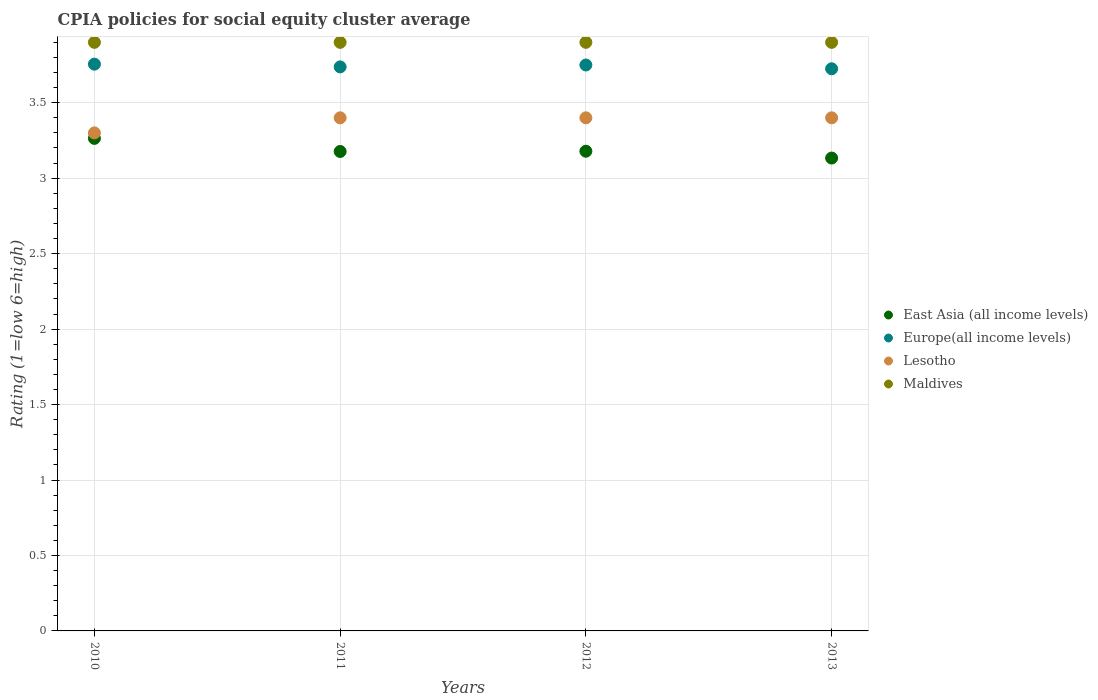Is the number of dotlines equal to the number of legend labels?
Ensure brevity in your answer.  Yes. What is the CPIA rating in Maldives in 2011?
Your answer should be compact. 3.9. Across all years, what is the maximum CPIA rating in East Asia (all income levels)?
Your response must be concise. 3.26. Across all years, what is the minimum CPIA rating in Maldives?
Make the answer very short. 3.9. What is the total CPIA rating in East Asia (all income levels) in the graph?
Your response must be concise. 12.75. What is the difference between the CPIA rating in Maldives in 2010 and that in 2012?
Provide a succinct answer. 0. What is the difference between the CPIA rating in Lesotho in 2011 and the CPIA rating in Europe(all income levels) in 2010?
Offer a terse response. -0.36. What is the average CPIA rating in Lesotho per year?
Provide a succinct answer. 3.38. In the year 2013, what is the difference between the CPIA rating in Europe(all income levels) and CPIA rating in Maldives?
Offer a very short reply. -0.17. What is the ratio of the CPIA rating in Lesotho in 2010 to that in 2011?
Your answer should be compact. 0.97. Is the CPIA rating in Europe(all income levels) in 2011 less than that in 2013?
Provide a succinct answer. No. Is the difference between the CPIA rating in Europe(all income levels) in 2010 and 2013 greater than the difference between the CPIA rating in Maldives in 2010 and 2013?
Your answer should be compact. Yes. What is the difference between the highest and the second highest CPIA rating in East Asia (all income levels)?
Your response must be concise. 0.09. Is the sum of the CPIA rating in Europe(all income levels) in 2010 and 2012 greater than the maximum CPIA rating in Lesotho across all years?
Offer a terse response. Yes. Is it the case that in every year, the sum of the CPIA rating in Lesotho and CPIA rating in Maldives  is greater than the sum of CPIA rating in Europe(all income levels) and CPIA rating in East Asia (all income levels)?
Offer a very short reply. No. Is it the case that in every year, the sum of the CPIA rating in Europe(all income levels) and CPIA rating in Lesotho  is greater than the CPIA rating in East Asia (all income levels)?
Provide a short and direct response. Yes. Does the CPIA rating in Lesotho monotonically increase over the years?
Your answer should be compact. No. How many dotlines are there?
Give a very brief answer. 4. What is the difference between two consecutive major ticks on the Y-axis?
Your answer should be very brief. 0.5. Are the values on the major ticks of Y-axis written in scientific E-notation?
Your answer should be compact. No. Does the graph contain any zero values?
Provide a succinct answer. No. How many legend labels are there?
Your answer should be very brief. 4. How are the legend labels stacked?
Give a very brief answer. Vertical. What is the title of the graph?
Your answer should be compact. CPIA policies for social equity cluster average. What is the label or title of the X-axis?
Your answer should be compact. Years. What is the Rating (1=low 6=high) in East Asia (all income levels) in 2010?
Provide a succinct answer. 3.26. What is the Rating (1=low 6=high) in Europe(all income levels) in 2010?
Offer a terse response. 3.76. What is the Rating (1=low 6=high) in East Asia (all income levels) in 2011?
Provide a succinct answer. 3.18. What is the Rating (1=low 6=high) of Europe(all income levels) in 2011?
Ensure brevity in your answer.  3.74. What is the Rating (1=low 6=high) of Maldives in 2011?
Make the answer very short. 3.9. What is the Rating (1=low 6=high) in East Asia (all income levels) in 2012?
Make the answer very short. 3.18. What is the Rating (1=low 6=high) in Europe(all income levels) in 2012?
Ensure brevity in your answer.  3.75. What is the Rating (1=low 6=high) of East Asia (all income levels) in 2013?
Your answer should be compact. 3.13. What is the Rating (1=low 6=high) of Europe(all income levels) in 2013?
Your answer should be very brief. 3.73. What is the Rating (1=low 6=high) in Maldives in 2013?
Provide a succinct answer. 3.9. Across all years, what is the maximum Rating (1=low 6=high) in East Asia (all income levels)?
Make the answer very short. 3.26. Across all years, what is the maximum Rating (1=low 6=high) in Europe(all income levels)?
Make the answer very short. 3.76. Across all years, what is the maximum Rating (1=low 6=high) in Maldives?
Your answer should be compact. 3.9. Across all years, what is the minimum Rating (1=low 6=high) in East Asia (all income levels)?
Provide a succinct answer. 3.13. Across all years, what is the minimum Rating (1=low 6=high) of Europe(all income levels)?
Your answer should be very brief. 3.73. What is the total Rating (1=low 6=high) in East Asia (all income levels) in the graph?
Offer a terse response. 12.75. What is the total Rating (1=low 6=high) in Europe(all income levels) in the graph?
Ensure brevity in your answer.  14.97. What is the total Rating (1=low 6=high) of Maldives in the graph?
Provide a short and direct response. 15.6. What is the difference between the Rating (1=low 6=high) of East Asia (all income levels) in 2010 and that in 2011?
Offer a terse response. 0.09. What is the difference between the Rating (1=low 6=high) of Europe(all income levels) in 2010 and that in 2011?
Make the answer very short. 0.02. What is the difference between the Rating (1=low 6=high) in Maldives in 2010 and that in 2011?
Provide a succinct answer. 0. What is the difference between the Rating (1=low 6=high) of East Asia (all income levels) in 2010 and that in 2012?
Ensure brevity in your answer.  0.09. What is the difference between the Rating (1=low 6=high) in Europe(all income levels) in 2010 and that in 2012?
Ensure brevity in your answer.  0.01. What is the difference between the Rating (1=low 6=high) in East Asia (all income levels) in 2010 and that in 2013?
Offer a very short reply. 0.13. What is the difference between the Rating (1=low 6=high) in Europe(all income levels) in 2010 and that in 2013?
Provide a succinct answer. 0.03. What is the difference between the Rating (1=low 6=high) of Lesotho in 2010 and that in 2013?
Your answer should be compact. -0.1. What is the difference between the Rating (1=low 6=high) of East Asia (all income levels) in 2011 and that in 2012?
Make the answer very short. -0. What is the difference between the Rating (1=low 6=high) in Europe(all income levels) in 2011 and that in 2012?
Offer a very short reply. -0.01. What is the difference between the Rating (1=low 6=high) in Lesotho in 2011 and that in 2012?
Make the answer very short. 0. What is the difference between the Rating (1=low 6=high) of Maldives in 2011 and that in 2012?
Provide a succinct answer. 0. What is the difference between the Rating (1=low 6=high) of East Asia (all income levels) in 2011 and that in 2013?
Make the answer very short. 0.04. What is the difference between the Rating (1=low 6=high) of Europe(all income levels) in 2011 and that in 2013?
Your answer should be compact. 0.01. What is the difference between the Rating (1=low 6=high) in Lesotho in 2011 and that in 2013?
Provide a succinct answer. 0. What is the difference between the Rating (1=low 6=high) in Maldives in 2011 and that in 2013?
Your answer should be very brief. 0. What is the difference between the Rating (1=low 6=high) in East Asia (all income levels) in 2012 and that in 2013?
Your answer should be very brief. 0.05. What is the difference between the Rating (1=low 6=high) in Europe(all income levels) in 2012 and that in 2013?
Make the answer very short. 0.03. What is the difference between the Rating (1=low 6=high) of East Asia (all income levels) in 2010 and the Rating (1=low 6=high) of Europe(all income levels) in 2011?
Your answer should be very brief. -0.47. What is the difference between the Rating (1=low 6=high) in East Asia (all income levels) in 2010 and the Rating (1=low 6=high) in Lesotho in 2011?
Ensure brevity in your answer.  -0.14. What is the difference between the Rating (1=low 6=high) of East Asia (all income levels) in 2010 and the Rating (1=low 6=high) of Maldives in 2011?
Your answer should be compact. -0.64. What is the difference between the Rating (1=low 6=high) in Europe(all income levels) in 2010 and the Rating (1=low 6=high) in Lesotho in 2011?
Your answer should be compact. 0.36. What is the difference between the Rating (1=low 6=high) in Europe(all income levels) in 2010 and the Rating (1=low 6=high) in Maldives in 2011?
Ensure brevity in your answer.  -0.14. What is the difference between the Rating (1=low 6=high) of Lesotho in 2010 and the Rating (1=low 6=high) of Maldives in 2011?
Give a very brief answer. -0.6. What is the difference between the Rating (1=low 6=high) of East Asia (all income levels) in 2010 and the Rating (1=low 6=high) of Europe(all income levels) in 2012?
Your answer should be compact. -0.49. What is the difference between the Rating (1=low 6=high) in East Asia (all income levels) in 2010 and the Rating (1=low 6=high) in Lesotho in 2012?
Give a very brief answer. -0.14. What is the difference between the Rating (1=low 6=high) of East Asia (all income levels) in 2010 and the Rating (1=low 6=high) of Maldives in 2012?
Offer a terse response. -0.64. What is the difference between the Rating (1=low 6=high) of Europe(all income levels) in 2010 and the Rating (1=low 6=high) of Lesotho in 2012?
Ensure brevity in your answer.  0.36. What is the difference between the Rating (1=low 6=high) of Europe(all income levels) in 2010 and the Rating (1=low 6=high) of Maldives in 2012?
Offer a terse response. -0.14. What is the difference between the Rating (1=low 6=high) in Lesotho in 2010 and the Rating (1=low 6=high) in Maldives in 2012?
Provide a short and direct response. -0.6. What is the difference between the Rating (1=low 6=high) of East Asia (all income levels) in 2010 and the Rating (1=low 6=high) of Europe(all income levels) in 2013?
Provide a succinct answer. -0.46. What is the difference between the Rating (1=low 6=high) in East Asia (all income levels) in 2010 and the Rating (1=low 6=high) in Lesotho in 2013?
Keep it short and to the point. -0.14. What is the difference between the Rating (1=low 6=high) of East Asia (all income levels) in 2010 and the Rating (1=low 6=high) of Maldives in 2013?
Your response must be concise. -0.64. What is the difference between the Rating (1=low 6=high) in Europe(all income levels) in 2010 and the Rating (1=low 6=high) in Lesotho in 2013?
Your answer should be very brief. 0.36. What is the difference between the Rating (1=low 6=high) in Europe(all income levels) in 2010 and the Rating (1=low 6=high) in Maldives in 2013?
Provide a succinct answer. -0.14. What is the difference between the Rating (1=low 6=high) of Lesotho in 2010 and the Rating (1=low 6=high) of Maldives in 2013?
Offer a very short reply. -0.6. What is the difference between the Rating (1=low 6=high) of East Asia (all income levels) in 2011 and the Rating (1=low 6=high) of Europe(all income levels) in 2012?
Make the answer very short. -0.57. What is the difference between the Rating (1=low 6=high) of East Asia (all income levels) in 2011 and the Rating (1=low 6=high) of Lesotho in 2012?
Keep it short and to the point. -0.22. What is the difference between the Rating (1=low 6=high) in East Asia (all income levels) in 2011 and the Rating (1=low 6=high) in Maldives in 2012?
Ensure brevity in your answer.  -0.72. What is the difference between the Rating (1=low 6=high) in Europe(all income levels) in 2011 and the Rating (1=low 6=high) in Lesotho in 2012?
Make the answer very short. 0.34. What is the difference between the Rating (1=low 6=high) of Europe(all income levels) in 2011 and the Rating (1=low 6=high) of Maldives in 2012?
Keep it short and to the point. -0.16. What is the difference between the Rating (1=low 6=high) in Lesotho in 2011 and the Rating (1=low 6=high) in Maldives in 2012?
Offer a terse response. -0.5. What is the difference between the Rating (1=low 6=high) of East Asia (all income levels) in 2011 and the Rating (1=low 6=high) of Europe(all income levels) in 2013?
Your answer should be compact. -0.55. What is the difference between the Rating (1=low 6=high) of East Asia (all income levels) in 2011 and the Rating (1=low 6=high) of Lesotho in 2013?
Provide a succinct answer. -0.22. What is the difference between the Rating (1=low 6=high) in East Asia (all income levels) in 2011 and the Rating (1=low 6=high) in Maldives in 2013?
Ensure brevity in your answer.  -0.72. What is the difference between the Rating (1=low 6=high) in Europe(all income levels) in 2011 and the Rating (1=low 6=high) in Lesotho in 2013?
Keep it short and to the point. 0.34. What is the difference between the Rating (1=low 6=high) in Europe(all income levels) in 2011 and the Rating (1=low 6=high) in Maldives in 2013?
Provide a short and direct response. -0.16. What is the difference between the Rating (1=low 6=high) in Lesotho in 2011 and the Rating (1=low 6=high) in Maldives in 2013?
Your answer should be compact. -0.5. What is the difference between the Rating (1=low 6=high) of East Asia (all income levels) in 2012 and the Rating (1=low 6=high) of Europe(all income levels) in 2013?
Make the answer very short. -0.55. What is the difference between the Rating (1=low 6=high) in East Asia (all income levels) in 2012 and the Rating (1=low 6=high) in Lesotho in 2013?
Provide a succinct answer. -0.22. What is the difference between the Rating (1=low 6=high) of East Asia (all income levels) in 2012 and the Rating (1=low 6=high) of Maldives in 2013?
Keep it short and to the point. -0.72. What is the difference between the Rating (1=low 6=high) of Europe(all income levels) in 2012 and the Rating (1=low 6=high) of Lesotho in 2013?
Provide a short and direct response. 0.35. What is the difference between the Rating (1=low 6=high) of Lesotho in 2012 and the Rating (1=low 6=high) of Maldives in 2013?
Ensure brevity in your answer.  -0.5. What is the average Rating (1=low 6=high) of East Asia (all income levels) per year?
Provide a short and direct response. 3.19. What is the average Rating (1=low 6=high) in Europe(all income levels) per year?
Give a very brief answer. 3.74. What is the average Rating (1=low 6=high) of Lesotho per year?
Offer a very short reply. 3.38. What is the average Rating (1=low 6=high) of Maldives per year?
Your answer should be very brief. 3.9. In the year 2010, what is the difference between the Rating (1=low 6=high) in East Asia (all income levels) and Rating (1=low 6=high) in Europe(all income levels)?
Your response must be concise. -0.49. In the year 2010, what is the difference between the Rating (1=low 6=high) of East Asia (all income levels) and Rating (1=low 6=high) of Lesotho?
Provide a short and direct response. -0.04. In the year 2010, what is the difference between the Rating (1=low 6=high) of East Asia (all income levels) and Rating (1=low 6=high) of Maldives?
Give a very brief answer. -0.64. In the year 2010, what is the difference between the Rating (1=low 6=high) of Europe(all income levels) and Rating (1=low 6=high) of Lesotho?
Ensure brevity in your answer.  0.46. In the year 2010, what is the difference between the Rating (1=low 6=high) in Europe(all income levels) and Rating (1=low 6=high) in Maldives?
Offer a terse response. -0.14. In the year 2011, what is the difference between the Rating (1=low 6=high) in East Asia (all income levels) and Rating (1=low 6=high) in Europe(all income levels)?
Provide a short and direct response. -0.56. In the year 2011, what is the difference between the Rating (1=low 6=high) of East Asia (all income levels) and Rating (1=low 6=high) of Lesotho?
Provide a succinct answer. -0.22. In the year 2011, what is the difference between the Rating (1=low 6=high) of East Asia (all income levels) and Rating (1=low 6=high) of Maldives?
Give a very brief answer. -0.72. In the year 2011, what is the difference between the Rating (1=low 6=high) of Europe(all income levels) and Rating (1=low 6=high) of Lesotho?
Offer a very short reply. 0.34. In the year 2011, what is the difference between the Rating (1=low 6=high) of Europe(all income levels) and Rating (1=low 6=high) of Maldives?
Make the answer very short. -0.16. In the year 2012, what is the difference between the Rating (1=low 6=high) in East Asia (all income levels) and Rating (1=low 6=high) in Europe(all income levels)?
Give a very brief answer. -0.57. In the year 2012, what is the difference between the Rating (1=low 6=high) in East Asia (all income levels) and Rating (1=low 6=high) in Lesotho?
Your answer should be compact. -0.22. In the year 2012, what is the difference between the Rating (1=low 6=high) in East Asia (all income levels) and Rating (1=low 6=high) in Maldives?
Offer a terse response. -0.72. In the year 2012, what is the difference between the Rating (1=low 6=high) in Europe(all income levels) and Rating (1=low 6=high) in Lesotho?
Your response must be concise. 0.35. In the year 2012, what is the difference between the Rating (1=low 6=high) in Lesotho and Rating (1=low 6=high) in Maldives?
Give a very brief answer. -0.5. In the year 2013, what is the difference between the Rating (1=low 6=high) of East Asia (all income levels) and Rating (1=low 6=high) of Europe(all income levels)?
Ensure brevity in your answer.  -0.59. In the year 2013, what is the difference between the Rating (1=low 6=high) in East Asia (all income levels) and Rating (1=low 6=high) in Lesotho?
Make the answer very short. -0.27. In the year 2013, what is the difference between the Rating (1=low 6=high) in East Asia (all income levels) and Rating (1=low 6=high) in Maldives?
Your response must be concise. -0.77. In the year 2013, what is the difference between the Rating (1=low 6=high) in Europe(all income levels) and Rating (1=low 6=high) in Lesotho?
Make the answer very short. 0.33. In the year 2013, what is the difference between the Rating (1=low 6=high) of Europe(all income levels) and Rating (1=low 6=high) of Maldives?
Offer a terse response. -0.17. What is the ratio of the Rating (1=low 6=high) in East Asia (all income levels) in 2010 to that in 2011?
Provide a succinct answer. 1.03. What is the ratio of the Rating (1=low 6=high) in Europe(all income levels) in 2010 to that in 2011?
Offer a very short reply. 1. What is the ratio of the Rating (1=low 6=high) in Lesotho in 2010 to that in 2011?
Offer a very short reply. 0.97. What is the ratio of the Rating (1=low 6=high) of East Asia (all income levels) in 2010 to that in 2012?
Ensure brevity in your answer.  1.03. What is the ratio of the Rating (1=low 6=high) of Europe(all income levels) in 2010 to that in 2012?
Ensure brevity in your answer.  1. What is the ratio of the Rating (1=low 6=high) in Lesotho in 2010 to that in 2012?
Offer a very short reply. 0.97. What is the ratio of the Rating (1=low 6=high) of East Asia (all income levels) in 2010 to that in 2013?
Your answer should be very brief. 1.04. What is the ratio of the Rating (1=low 6=high) in Europe(all income levels) in 2010 to that in 2013?
Offer a terse response. 1.01. What is the ratio of the Rating (1=low 6=high) of Lesotho in 2010 to that in 2013?
Keep it short and to the point. 0.97. What is the ratio of the Rating (1=low 6=high) in Maldives in 2010 to that in 2013?
Ensure brevity in your answer.  1. What is the ratio of the Rating (1=low 6=high) of East Asia (all income levels) in 2011 to that in 2013?
Give a very brief answer. 1.01. What is the ratio of the Rating (1=low 6=high) of Europe(all income levels) in 2011 to that in 2013?
Your response must be concise. 1. What is the ratio of the Rating (1=low 6=high) of Lesotho in 2011 to that in 2013?
Keep it short and to the point. 1. What is the ratio of the Rating (1=low 6=high) in East Asia (all income levels) in 2012 to that in 2013?
Provide a short and direct response. 1.01. What is the difference between the highest and the second highest Rating (1=low 6=high) of East Asia (all income levels)?
Your response must be concise. 0.09. What is the difference between the highest and the second highest Rating (1=low 6=high) of Europe(all income levels)?
Ensure brevity in your answer.  0.01. What is the difference between the highest and the second highest Rating (1=low 6=high) in Lesotho?
Keep it short and to the point. 0. What is the difference between the highest and the lowest Rating (1=low 6=high) of East Asia (all income levels)?
Provide a succinct answer. 0.13. What is the difference between the highest and the lowest Rating (1=low 6=high) in Europe(all income levels)?
Make the answer very short. 0.03. What is the difference between the highest and the lowest Rating (1=low 6=high) in Maldives?
Your answer should be compact. 0. 